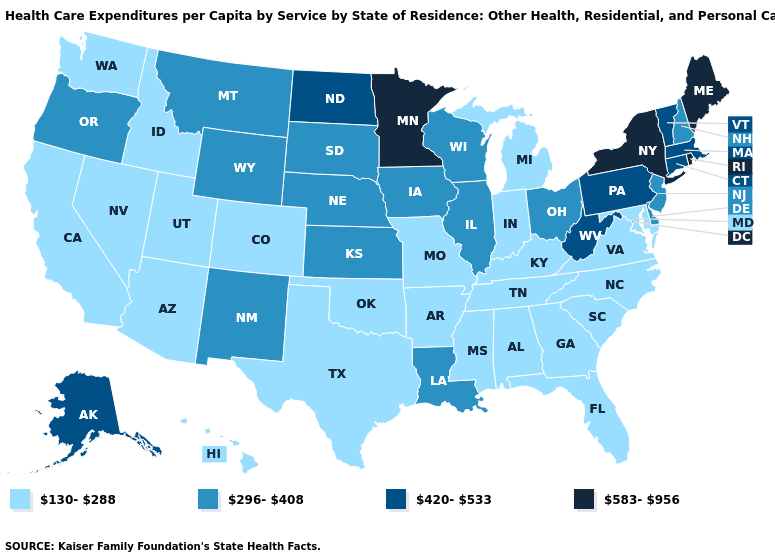Name the states that have a value in the range 420-533?
Write a very short answer. Alaska, Connecticut, Massachusetts, North Dakota, Pennsylvania, Vermont, West Virginia. Name the states that have a value in the range 130-288?
Keep it brief. Alabama, Arizona, Arkansas, California, Colorado, Florida, Georgia, Hawaii, Idaho, Indiana, Kentucky, Maryland, Michigan, Mississippi, Missouri, Nevada, North Carolina, Oklahoma, South Carolina, Tennessee, Texas, Utah, Virginia, Washington. What is the lowest value in states that border Tennessee?
Answer briefly. 130-288. Among the states that border Kansas , does Nebraska have the highest value?
Be succinct. Yes. Does North Dakota have the lowest value in the MidWest?
Keep it brief. No. What is the value of Utah?
Write a very short answer. 130-288. How many symbols are there in the legend?
Answer briefly. 4. Which states have the lowest value in the USA?
Keep it brief. Alabama, Arizona, Arkansas, California, Colorado, Florida, Georgia, Hawaii, Idaho, Indiana, Kentucky, Maryland, Michigan, Mississippi, Missouri, Nevada, North Carolina, Oklahoma, South Carolina, Tennessee, Texas, Utah, Virginia, Washington. Among the states that border Illinois , does Kentucky have the highest value?
Keep it brief. No. What is the value of North Carolina?
Short answer required. 130-288. Among the states that border Texas , does Louisiana have the lowest value?
Quick response, please. No. Does Tennessee have a lower value than Iowa?
Be succinct. Yes. What is the value of Pennsylvania?
Give a very brief answer. 420-533. Does Minnesota have the highest value in the MidWest?
Short answer required. Yes. Does Missouri have the lowest value in the MidWest?
Short answer required. Yes. 